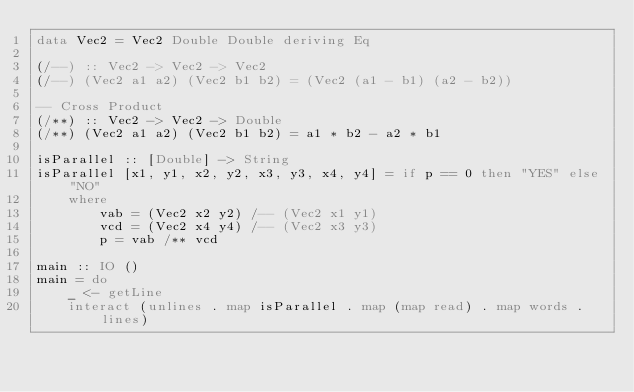Convert code to text. <code><loc_0><loc_0><loc_500><loc_500><_Haskell_>data Vec2 = Vec2 Double Double deriving Eq

(/--) :: Vec2 -> Vec2 -> Vec2
(/--) (Vec2 a1 a2) (Vec2 b1 b2) = (Vec2 (a1 - b1) (a2 - b2))

-- Cross Product
(/**) :: Vec2 -> Vec2 -> Double
(/**) (Vec2 a1 a2) (Vec2 b1 b2) = a1 * b2 - a2 * b1

isParallel :: [Double] -> String
isParallel [x1, y1, x2, y2, x3, y3, x4, y4] = if p == 0 then "YES" else "NO"
    where
        vab = (Vec2 x2 y2) /-- (Vec2 x1 y1)
        vcd = (Vec2 x4 y4) /-- (Vec2 x3 y3)
        p = vab /** vcd

main :: IO ()
main = do
    _ <- getLine
    interact (unlines . map isParallel . map (map read) . map words . lines)</code> 